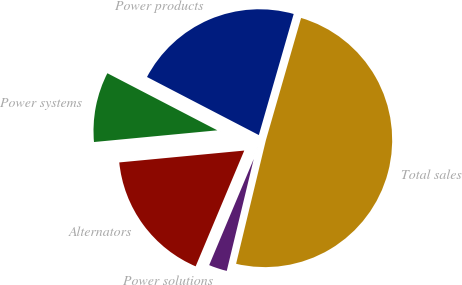<chart> <loc_0><loc_0><loc_500><loc_500><pie_chart><fcel>Power products<fcel>Power systems<fcel>Alternators<fcel>Power solutions<fcel>Total sales<nl><fcel>21.84%<fcel>9.13%<fcel>17.17%<fcel>2.56%<fcel>49.31%<nl></chart> 